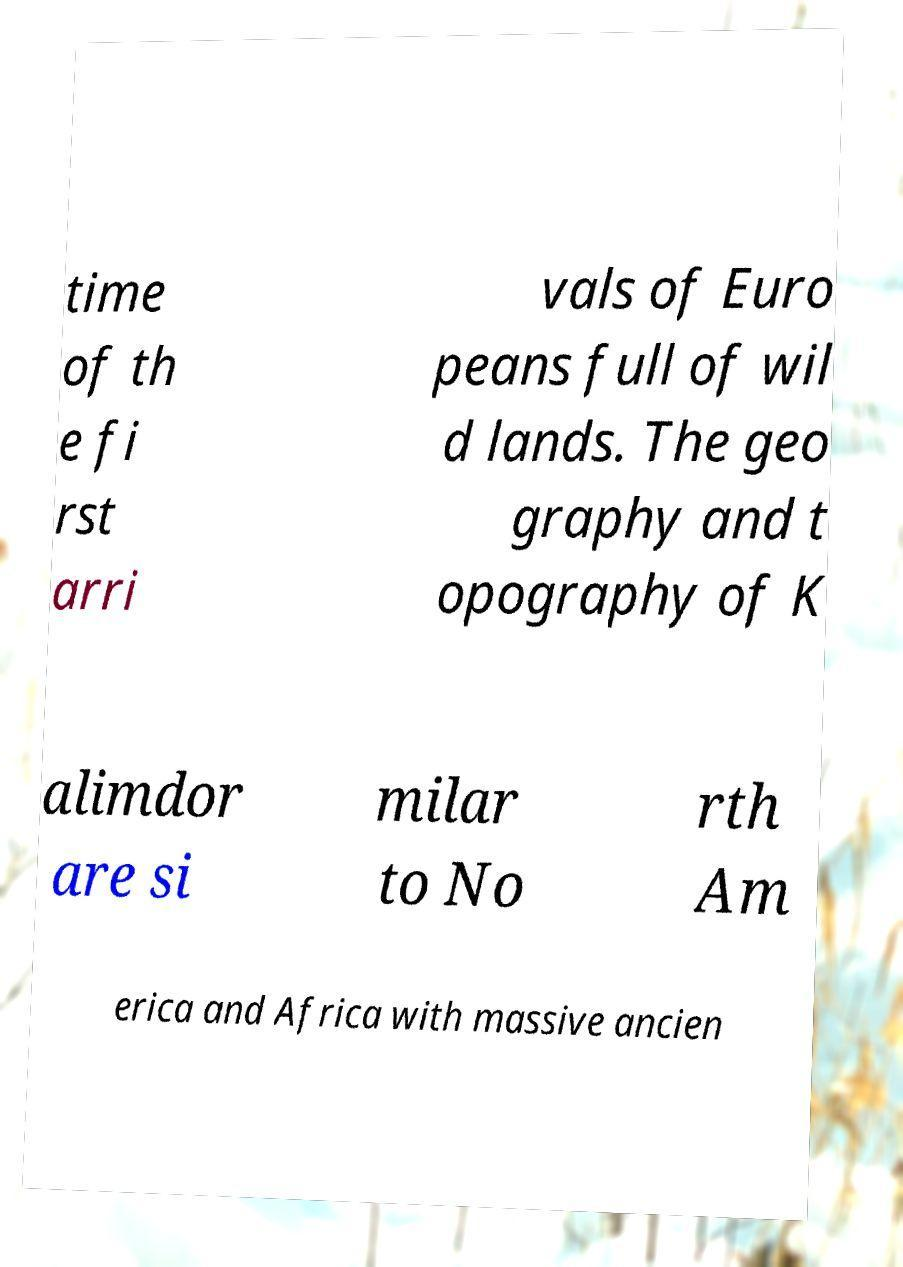I need the written content from this picture converted into text. Can you do that? time of th e fi rst arri vals of Euro peans full of wil d lands. The geo graphy and t opography of K alimdor are si milar to No rth Am erica and Africa with massive ancien 